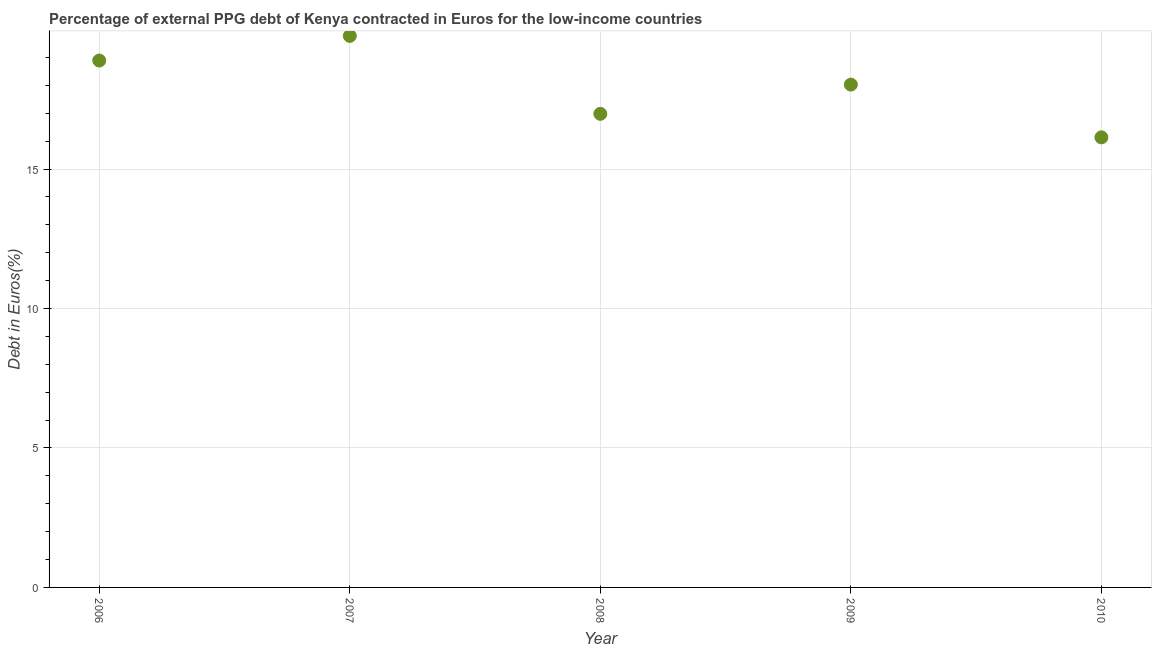What is the currency composition of ppg debt in 2006?
Make the answer very short. 18.89. Across all years, what is the maximum currency composition of ppg debt?
Offer a very short reply. 19.77. Across all years, what is the minimum currency composition of ppg debt?
Offer a very short reply. 16.14. In which year was the currency composition of ppg debt maximum?
Give a very brief answer. 2007. What is the sum of the currency composition of ppg debt?
Provide a succinct answer. 89.81. What is the difference between the currency composition of ppg debt in 2009 and 2010?
Offer a very short reply. 1.89. What is the average currency composition of ppg debt per year?
Offer a very short reply. 17.96. What is the median currency composition of ppg debt?
Offer a very short reply. 18.03. Do a majority of the years between 2009 and 2006 (inclusive) have currency composition of ppg debt greater than 6 %?
Make the answer very short. Yes. What is the ratio of the currency composition of ppg debt in 2006 to that in 2007?
Make the answer very short. 0.96. What is the difference between the highest and the second highest currency composition of ppg debt?
Keep it short and to the point. 0.88. What is the difference between the highest and the lowest currency composition of ppg debt?
Ensure brevity in your answer.  3.64. How many dotlines are there?
Offer a very short reply. 1. How many years are there in the graph?
Offer a terse response. 5. What is the title of the graph?
Your answer should be very brief. Percentage of external PPG debt of Kenya contracted in Euros for the low-income countries. What is the label or title of the Y-axis?
Ensure brevity in your answer.  Debt in Euros(%). What is the Debt in Euros(%) in 2006?
Your answer should be very brief. 18.89. What is the Debt in Euros(%) in 2007?
Offer a very short reply. 19.77. What is the Debt in Euros(%) in 2008?
Offer a very short reply. 16.98. What is the Debt in Euros(%) in 2009?
Make the answer very short. 18.03. What is the Debt in Euros(%) in 2010?
Your answer should be compact. 16.14. What is the difference between the Debt in Euros(%) in 2006 and 2007?
Your answer should be very brief. -0.88. What is the difference between the Debt in Euros(%) in 2006 and 2008?
Offer a very short reply. 1.91. What is the difference between the Debt in Euros(%) in 2006 and 2009?
Your answer should be very brief. 0.86. What is the difference between the Debt in Euros(%) in 2006 and 2010?
Ensure brevity in your answer.  2.75. What is the difference between the Debt in Euros(%) in 2007 and 2008?
Offer a very short reply. 2.79. What is the difference between the Debt in Euros(%) in 2007 and 2009?
Provide a short and direct response. 1.75. What is the difference between the Debt in Euros(%) in 2007 and 2010?
Ensure brevity in your answer.  3.64. What is the difference between the Debt in Euros(%) in 2008 and 2009?
Keep it short and to the point. -1.05. What is the difference between the Debt in Euros(%) in 2008 and 2010?
Provide a succinct answer. 0.84. What is the difference between the Debt in Euros(%) in 2009 and 2010?
Give a very brief answer. 1.89. What is the ratio of the Debt in Euros(%) in 2006 to that in 2007?
Keep it short and to the point. 0.95. What is the ratio of the Debt in Euros(%) in 2006 to that in 2008?
Your answer should be compact. 1.11. What is the ratio of the Debt in Euros(%) in 2006 to that in 2009?
Ensure brevity in your answer.  1.05. What is the ratio of the Debt in Euros(%) in 2006 to that in 2010?
Ensure brevity in your answer.  1.17. What is the ratio of the Debt in Euros(%) in 2007 to that in 2008?
Your response must be concise. 1.17. What is the ratio of the Debt in Euros(%) in 2007 to that in 2009?
Offer a very short reply. 1.1. What is the ratio of the Debt in Euros(%) in 2007 to that in 2010?
Provide a short and direct response. 1.23. What is the ratio of the Debt in Euros(%) in 2008 to that in 2009?
Offer a very short reply. 0.94. What is the ratio of the Debt in Euros(%) in 2008 to that in 2010?
Your answer should be very brief. 1.05. What is the ratio of the Debt in Euros(%) in 2009 to that in 2010?
Keep it short and to the point. 1.12. 